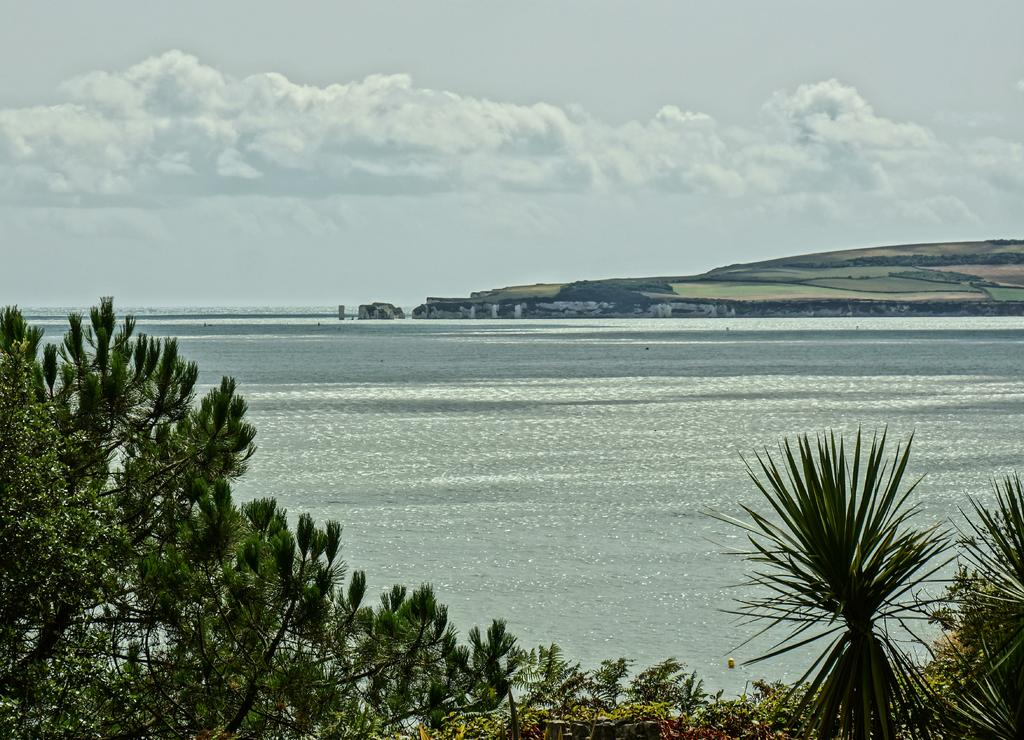What type of natural landscape is depicted in the image? The image features a sea, a hill, agricultural fields, and many trees. What is the weather like in the image? The sky is cloudy in the image, suggesting a potentially overcast or rainy day. Can you describe the terrain in the image? The image includes a hill and agricultural fields, indicating a varied landscape. What type of cabbage can be seen growing in the agricultural fields in the image? There is no specific type of cabbage mentioned or visible in the image. Can you tell me how many socks are hanging on the trees in the image? There are no socks present in the image; it features a sea, a hill, agricultural fields, and many trees. 